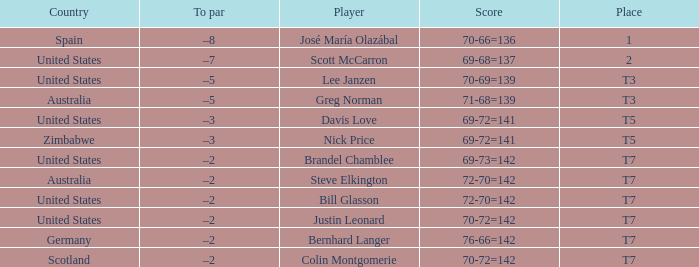Name the Player who has a Country of united states, and a To par of –5? Lee Janzen. 